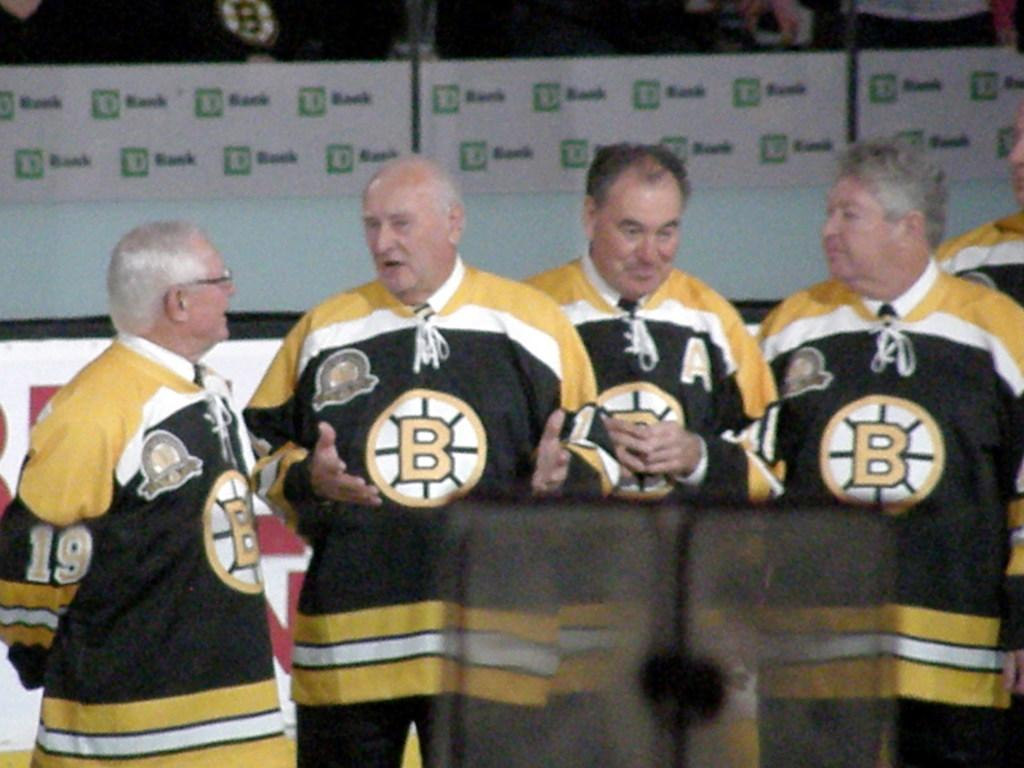<image>
Describe the image concisely. Four older men sare standing and talking. They are wearing yellow and black sweatshirts that say "B" on them. 